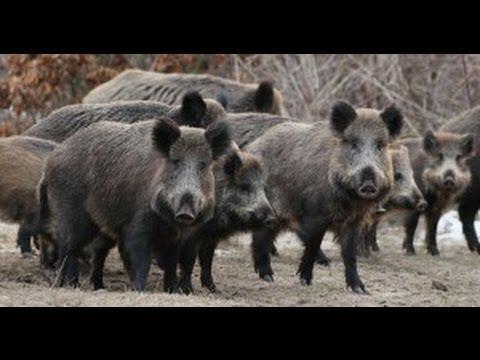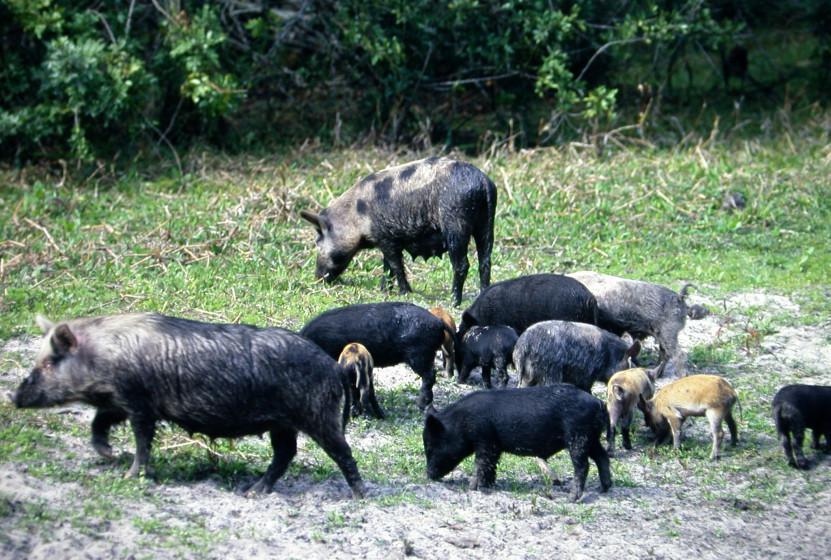The first image is the image on the left, the second image is the image on the right. Given the left and right images, does the statement "One image contains no more than 4 pigs." hold true? Answer yes or no. No. The first image is the image on the left, the second image is the image on the right. For the images shown, is this caption "One of the images shows only 4 animals." true? Answer yes or no. No. 